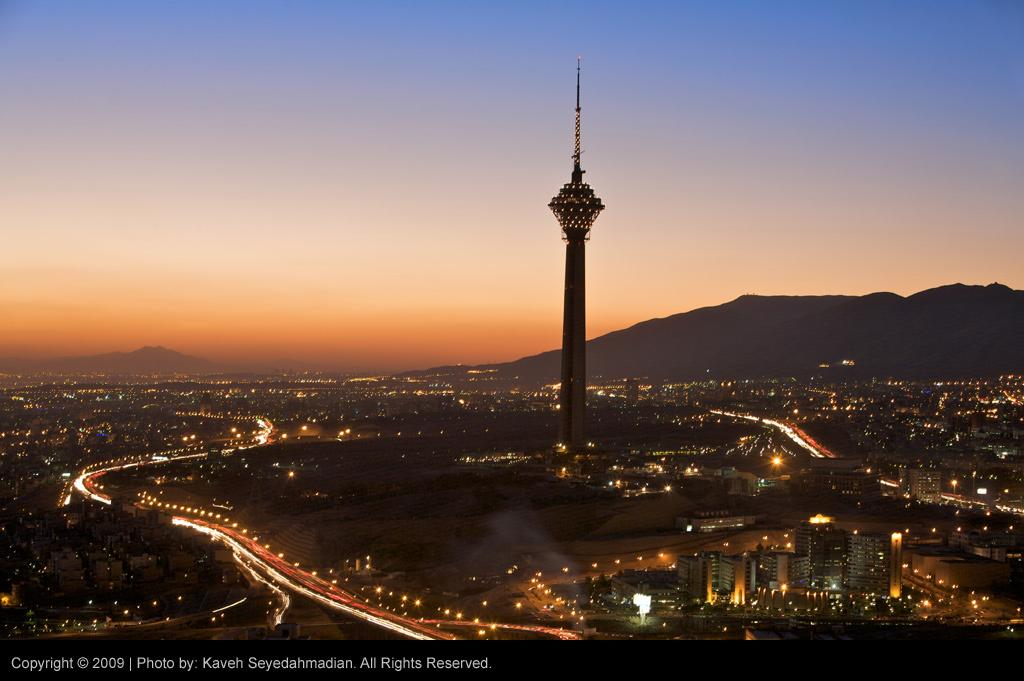What type of structures can be seen in the image? There are buildings and a tower in the image. What can be found on the buildings or tower? There are lights visible on the buildings or tower. What is visible in the background of the image? Hills and the sky are visible in the background of the image. Where is the text located in the image? The text is in the bottom left side of the image. What type of ornament is hanging from the sheet in the image? There is no sheet or ornament present in the image. 